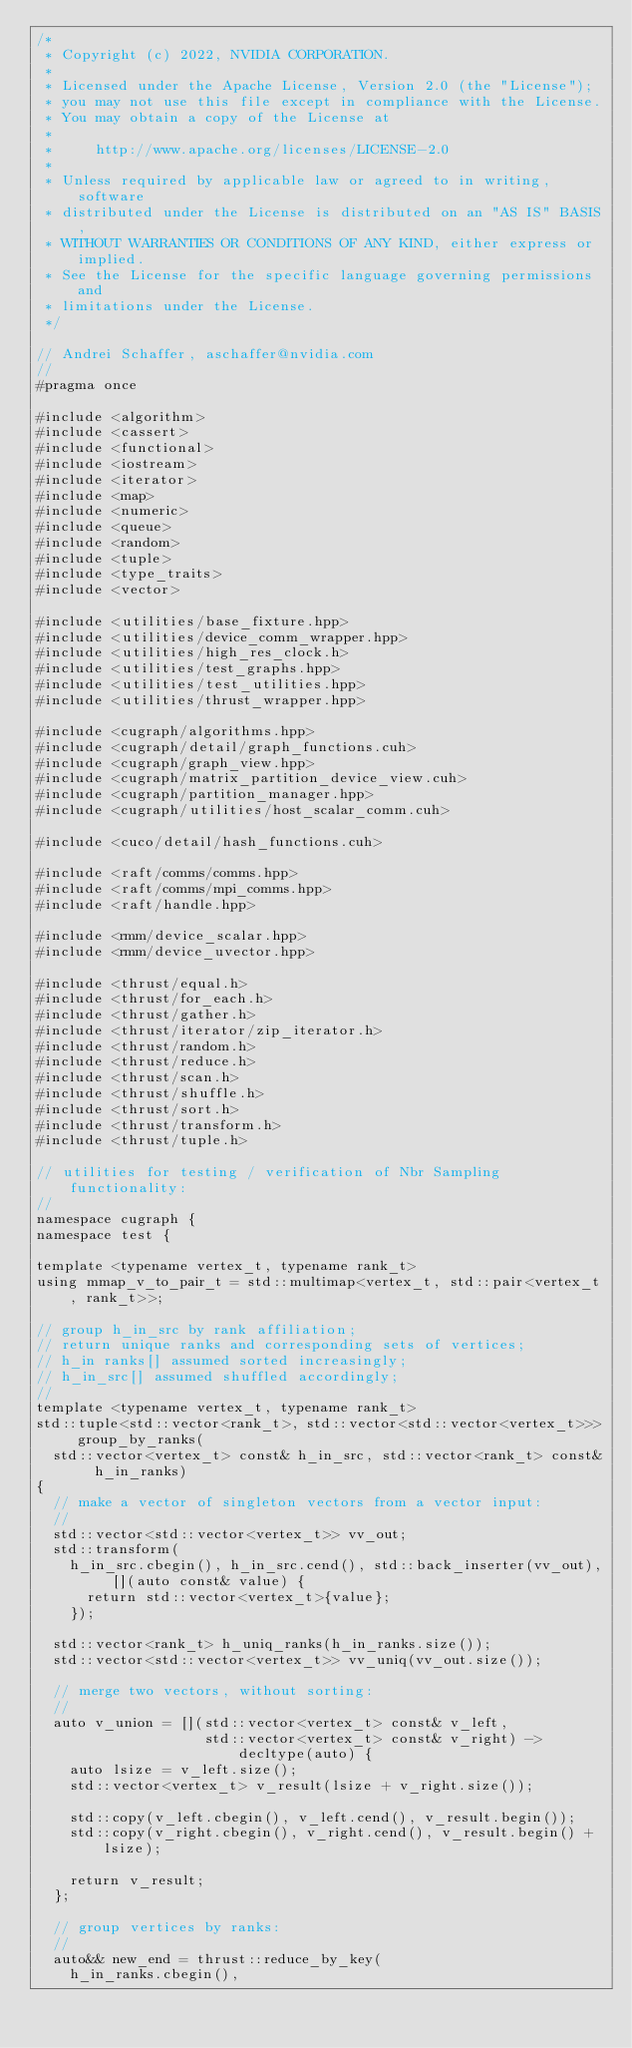Convert code to text. <code><loc_0><loc_0><loc_500><loc_500><_Cuda_>/*
 * Copyright (c) 2022, NVIDIA CORPORATION.
 *
 * Licensed under the Apache License, Version 2.0 (the "License");
 * you may not use this file except in compliance with the License.
 * You may obtain a copy of the License at
 *
 *     http://www.apache.org/licenses/LICENSE-2.0
 *
 * Unless required by applicable law or agreed to in writing, software
 * distributed under the License is distributed on an "AS IS" BASIS,
 * WITHOUT WARRANTIES OR CONDITIONS OF ANY KIND, either express or implied.
 * See the License for the specific language governing permissions and
 * limitations under the License.
 */

// Andrei Schaffer, aschaffer@nvidia.com
//
#pragma once

#include <algorithm>
#include <cassert>
#include <functional>
#include <iostream>
#include <iterator>
#include <map>
#include <numeric>
#include <queue>
#include <random>
#include <tuple>
#include <type_traits>
#include <vector>

#include <utilities/base_fixture.hpp>
#include <utilities/device_comm_wrapper.hpp>
#include <utilities/high_res_clock.h>
#include <utilities/test_graphs.hpp>
#include <utilities/test_utilities.hpp>
#include <utilities/thrust_wrapper.hpp>

#include <cugraph/algorithms.hpp>
#include <cugraph/detail/graph_functions.cuh>
#include <cugraph/graph_view.hpp>
#include <cugraph/matrix_partition_device_view.cuh>
#include <cugraph/partition_manager.hpp>
#include <cugraph/utilities/host_scalar_comm.cuh>

#include <cuco/detail/hash_functions.cuh>

#include <raft/comms/comms.hpp>
#include <raft/comms/mpi_comms.hpp>
#include <raft/handle.hpp>

#include <rmm/device_scalar.hpp>
#include <rmm/device_uvector.hpp>

#include <thrust/equal.h>
#include <thrust/for_each.h>
#include <thrust/gather.h>
#include <thrust/iterator/zip_iterator.h>
#include <thrust/random.h>
#include <thrust/reduce.h>
#include <thrust/scan.h>
#include <thrust/shuffle.h>
#include <thrust/sort.h>
#include <thrust/transform.h>
#include <thrust/tuple.h>

// utilities for testing / verification of Nbr Sampling functionality:
//
namespace cugraph {
namespace test {

template <typename vertex_t, typename rank_t>
using mmap_v_to_pair_t = std::multimap<vertex_t, std::pair<vertex_t, rank_t>>;

// group h_in_src by rank affiliation;
// return unique ranks and corresponding sets of vertices;
// h_in ranks[] assumed sorted increasingly;
// h_in_src[] assumed shuffled accordingly;
//
template <typename vertex_t, typename rank_t>
std::tuple<std::vector<rank_t>, std::vector<std::vector<vertex_t>>> group_by_ranks(
  std::vector<vertex_t> const& h_in_src, std::vector<rank_t> const& h_in_ranks)
{
  // make a vector of singleton vectors from a vector input:
  //
  std::vector<std::vector<vertex_t>> vv_out;
  std::transform(
    h_in_src.cbegin(), h_in_src.cend(), std::back_inserter(vv_out), [](auto const& value) {
      return std::vector<vertex_t>{value};
    });

  std::vector<rank_t> h_uniq_ranks(h_in_ranks.size());
  std::vector<std::vector<vertex_t>> vv_uniq(vv_out.size());

  // merge two vectors, without sorting:
  //
  auto v_union = [](std::vector<vertex_t> const& v_left,
                    std::vector<vertex_t> const& v_right) -> decltype(auto) {
    auto lsize = v_left.size();
    std::vector<vertex_t> v_result(lsize + v_right.size());

    std::copy(v_left.cbegin(), v_left.cend(), v_result.begin());
    std::copy(v_right.cbegin(), v_right.cend(), v_result.begin() + lsize);

    return v_result;
  };

  // group vertices by ranks:
  //
  auto&& new_end = thrust::reduce_by_key(
    h_in_ranks.cbegin(),</code> 